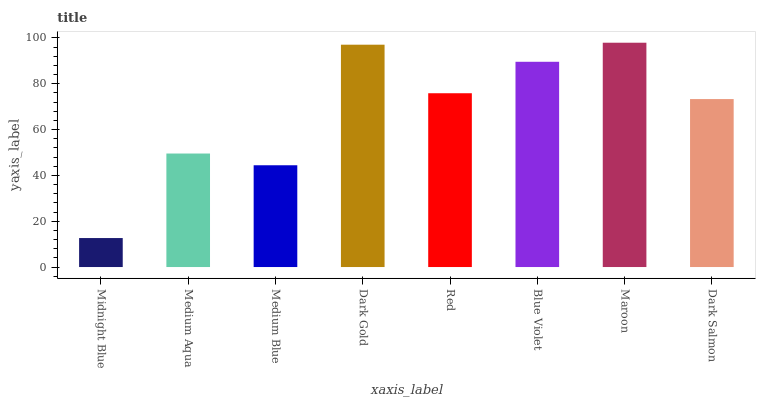Is Midnight Blue the minimum?
Answer yes or no. Yes. Is Maroon the maximum?
Answer yes or no. Yes. Is Medium Aqua the minimum?
Answer yes or no. No. Is Medium Aqua the maximum?
Answer yes or no. No. Is Medium Aqua greater than Midnight Blue?
Answer yes or no. Yes. Is Midnight Blue less than Medium Aqua?
Answer yes or no. Yes. Is Midnight Blue greater than Medium Aqua?
Answer yes or no. No. Is Medium Aqua less than Midnight Blue?
Answer yes or no. No. Is Red the high median?
Answer yes or no. Yes. Is Dark Salmon the low median?
Answer yes or no. Yes. Is Dark Salmon the high median?
Answer yes or no. No. Is Red the low median?
Answer yes or no. No. 